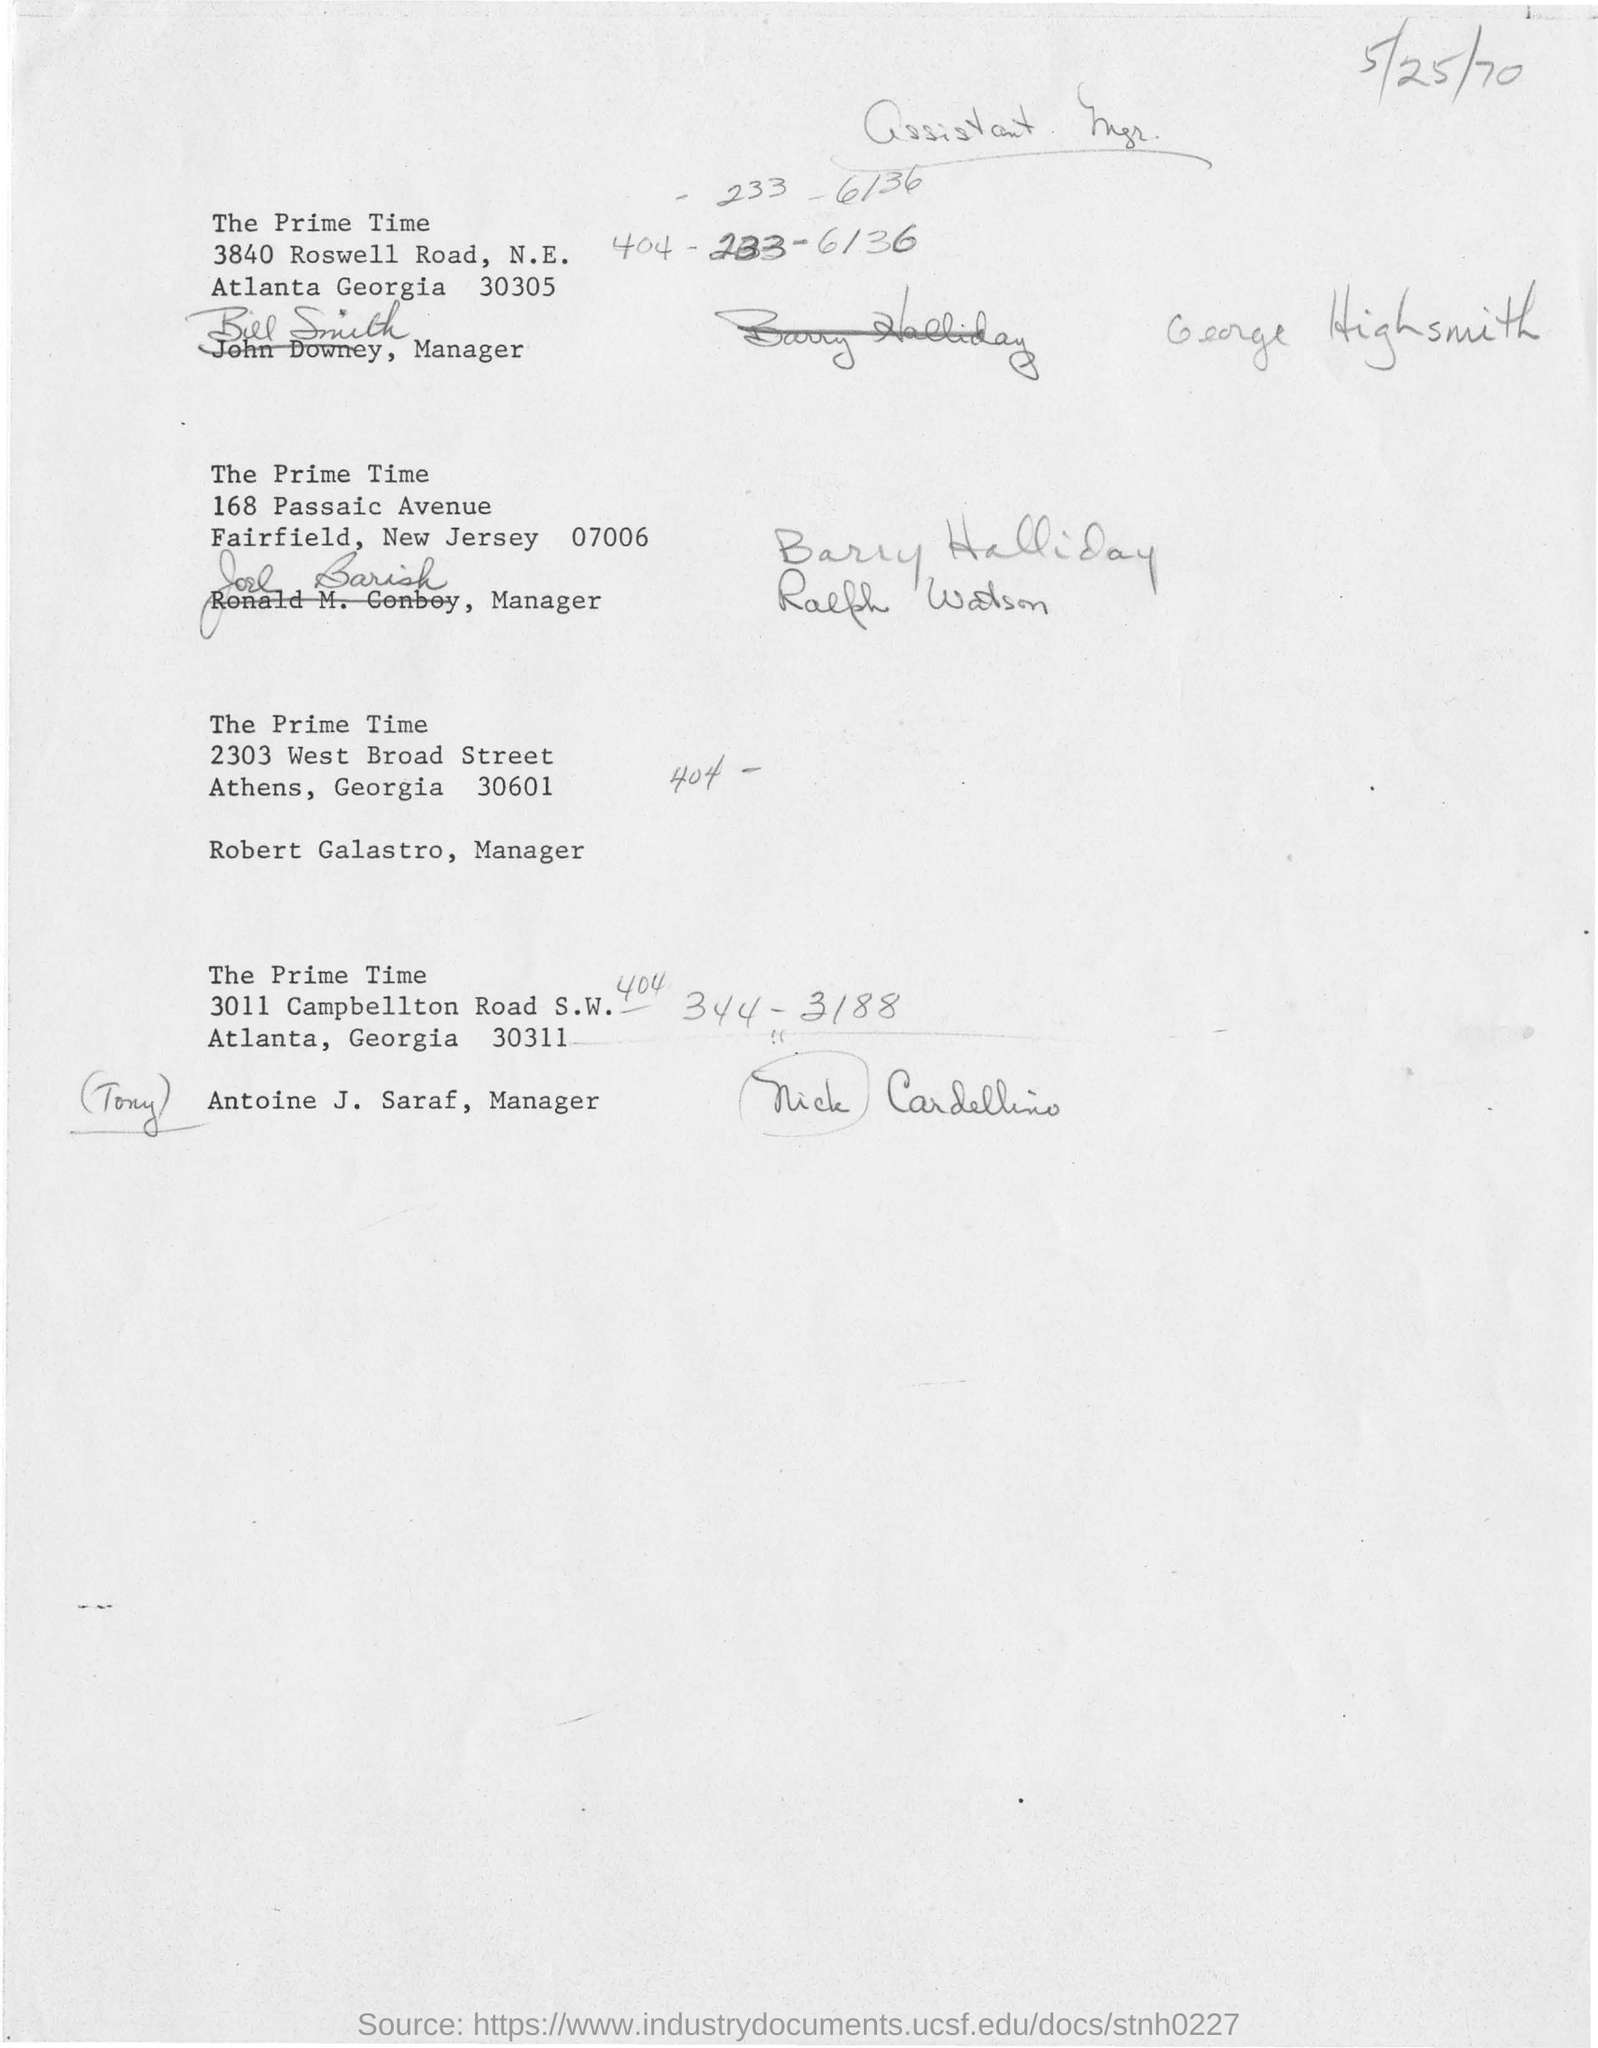Give some essential details in this illustration. The document contains a handwritten note in the top left corner with a date written in pencil, which reads "5/25/70". The date is written in a casual and informal manner, suggesting that it was likely made during a personal or unofficial setting, rather than a formal or professional one. The manager at the location of 3840 Roswell Road, N.E. Atlanta, Georgia 30305 is Bill Smith. I, ROBERT GALASTRO, am the manager from the location of Athens, Georgia 30601. 168 Passaic Avenue is located on Avenue in which the prime times can be found. The location of "the prime time" is in 3840 Roswell Road in the city of Atlanta, Georgia 30305. 